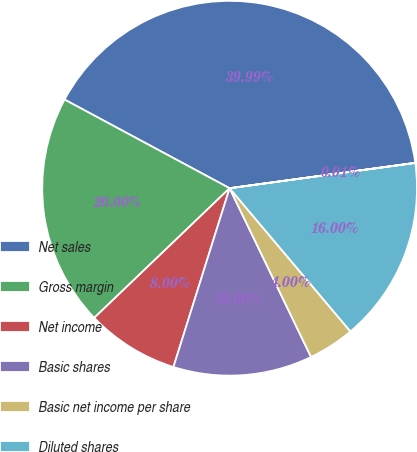<chart> <loc_0><loc_0><loc_500><loc_500><pie_chart><fcel>Net sales<fcel>Gross margin<fcel>Net income<fcel>Basic shares<fcel>Basic net income per share<fcel>Diluted shares<fcel>Diluted net income per share<nl><fcel>39.99%<fcel>20.0%<fcel>8.0%<fcel>12.0%<fcel>4.0%<fcel>16.0%<fcel>0.01%<nl></chart> 